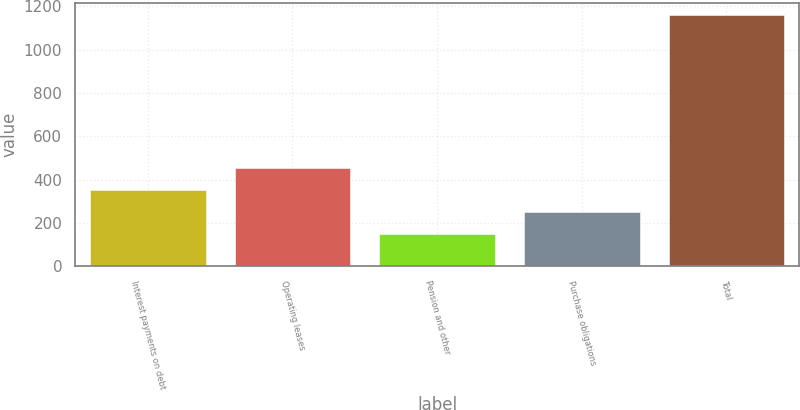<chart> <loc_0><loc_0><loc_500><loc_500><bar_chart><fcel>Interest payments on debt<fcel>Operating leases<fcel>Pension and other<fcel>Purchase obligations<fcel>Total<nl><fcel>351.6<fcel>452.4<fcel>150<fcel>250.8<fcel>1158<nl></chart> 